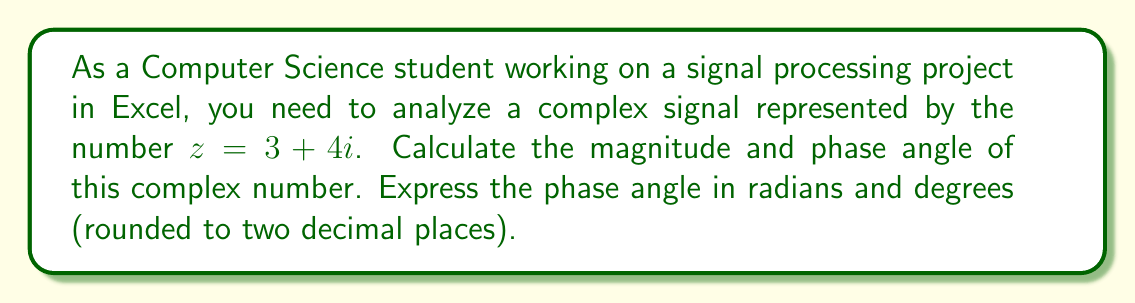Solve this math problem. To calculate the magnitude and phase of a complex number $z = a + bi$, we use the following formulas:

1. Magnitude (r): $r = \sqrt{a^2 + b^2}$
2. Phase angle (θ) in radians: $\theta = \tan^{-1}(\frac{b}{a})$

For the given complex number $z = 3 + 4i$:

1. Calculating the magnitude:
   $$r = \sqrt{3^2 + 4^2} = \sqrt{9 + 16} = \sqrt{25} = 5$$

2. Calculating the phase angle in radians:
   $$\theta = \tan^{-1}(\frac{4}{3}) \approx 0.9273 \text{ radians}$$

3. Converting radians to degrees:
   $$\theta_{degrees} = \theta_{radians} \times \frac{180^{\circ}}{\pi} \approx 0.9273 \times \frac{180^{\circ}}{\pi} \approx 53.13^{\circ}$$

In Excel, you can use the following functions to perform these calculations:
- Magnitude: `=SQRT(IMREAL(z)^2 + IMAGINARY(z)^2)`
- Phase (radians): `=ATAN2(IMAGINARY(z), IMREAL(z))`
- Phase (degrees): `=DEGREES(ATAN2(IMAGINARY(z), IMREAL(z)))`

Where `z` is the cell containing the complex number in the form "3+4i".
Answer: Magnitude: 5
Phase angle: 0.93 radians or 53.13 degrees 